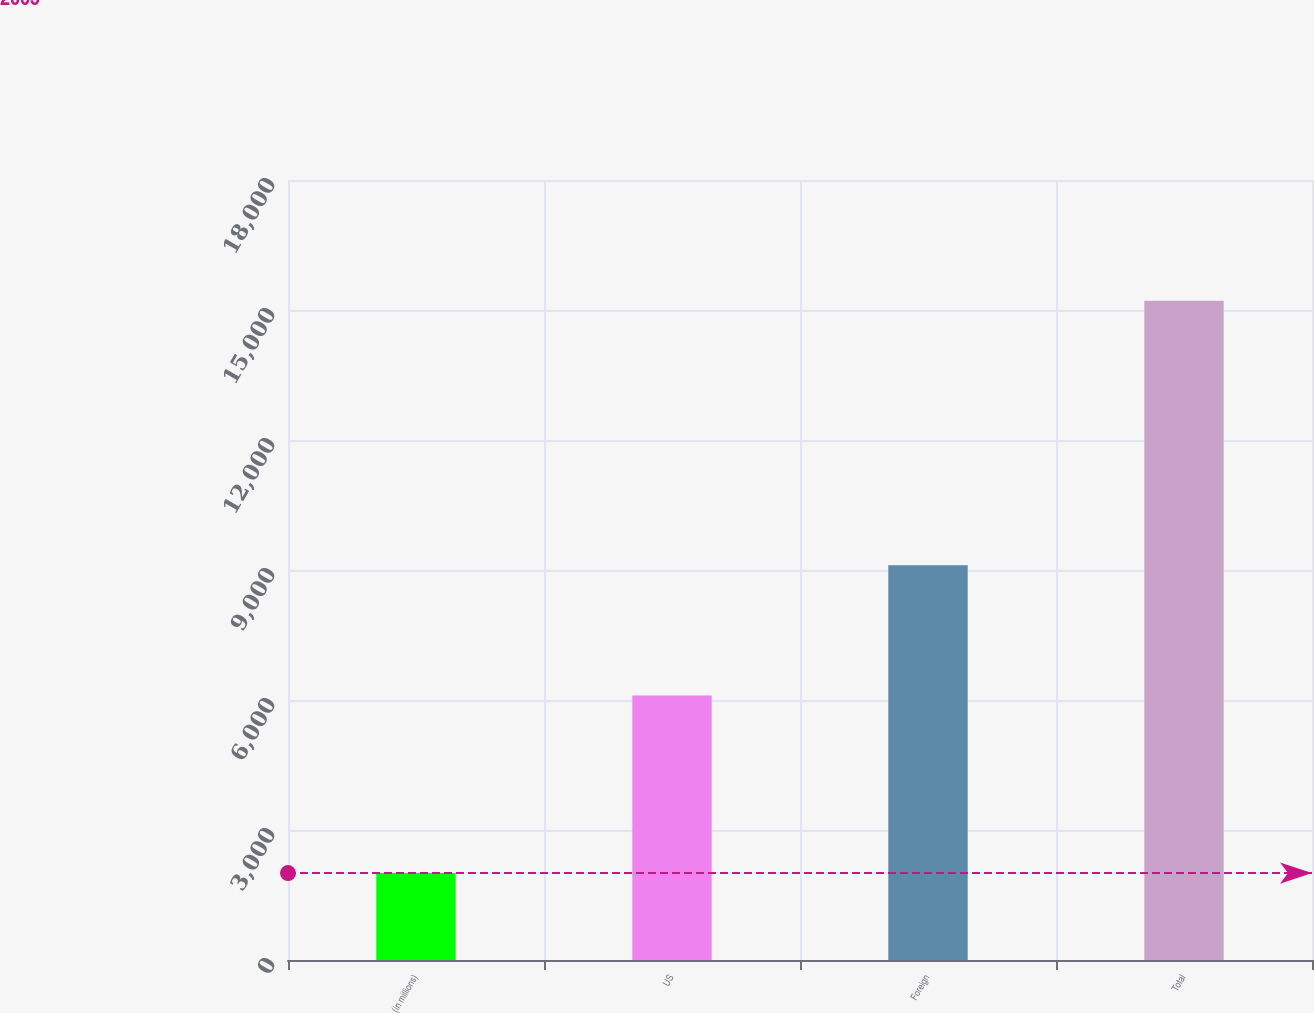<chart> <loc_0><loc_0><loc_500><loc_500><bar_chart><fcel>(in millions)<fcel>US<fcel>Foreign<fcel>Total<nl><fcel>2005<fcel>6103<fcel>9110<fcel>15213<nl></chart> 